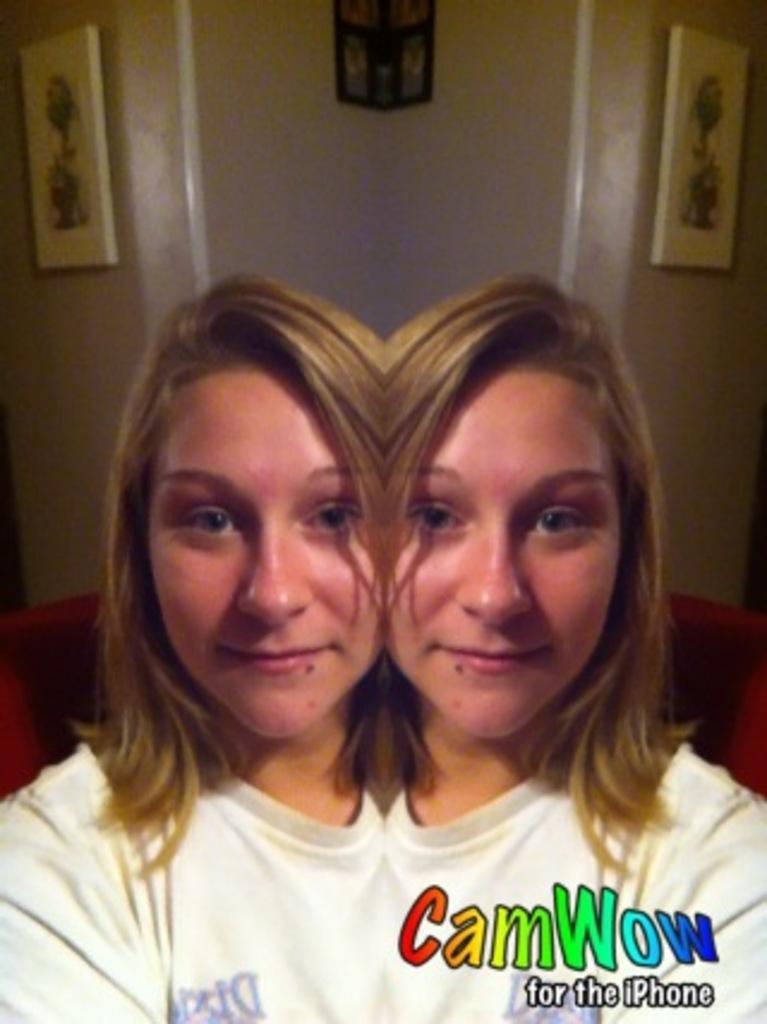Describe this image in one or two sentences. In this mirror effect photo there is a woman. She is smiling. Behind her there is a wall. There are picture frames on the wall. In the bottom right there is text on the wall. 